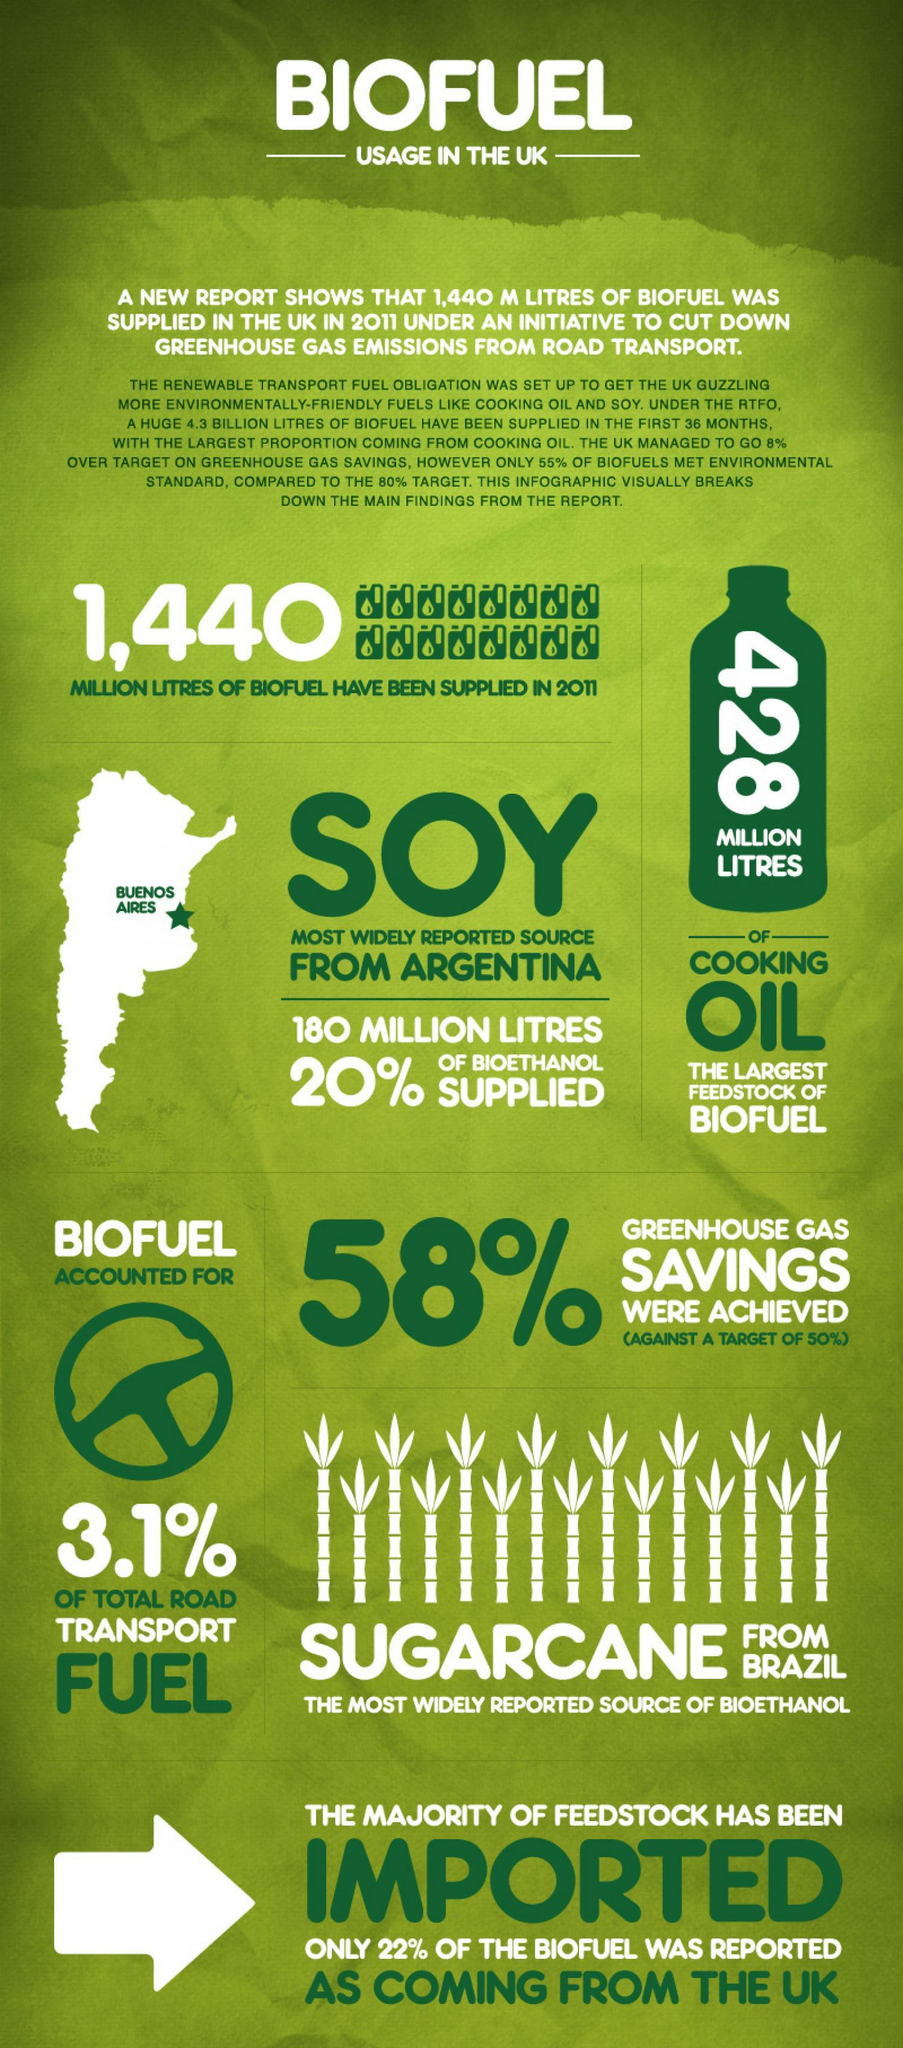what is the number written vertically on the green bottle vector image?
Answer the question with a short phrase. 428 what is the major source of bioethanol? sugarcane What is the color of heading text - green or white? white the percentage of greenhouse gas savings that exceeds the target is? 8 how many images of sugar cane is given in this infographic? 15 what is the percentage of biofuel that has been imported UK? 78 What is the color of the arrow symbol -white or green? white Find the count of the number "1440" in this infographic? 2 